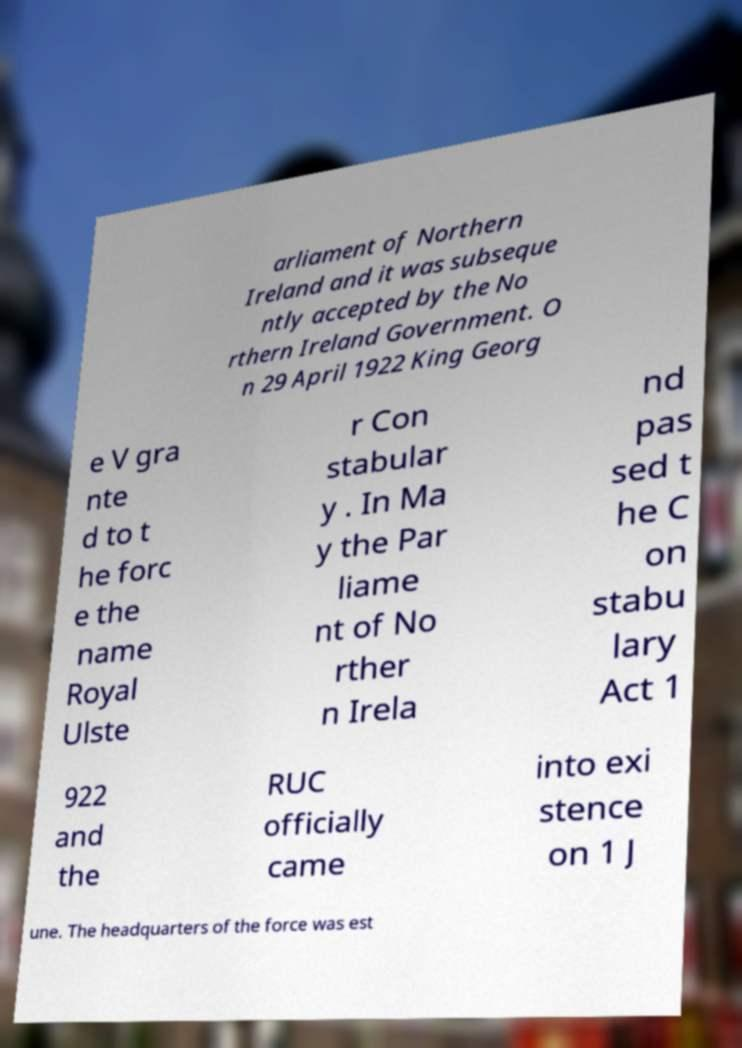Please read and relay the text visible in this image. What does it say? arliament of Northern Ireland and it was subseque ntly accepted by the No rthern Ireland Government. O n 29 April 1922 King Georg e V gra nte d to t he forc e the name Royal Ulste r Con stabular y . In Ma y the Par liame nt of No rther n Irela nd pas sed t he C on stabu lary Act 1 922 and the RUC officially came into exi stence on 1 J une. The headquarters of the force was est 